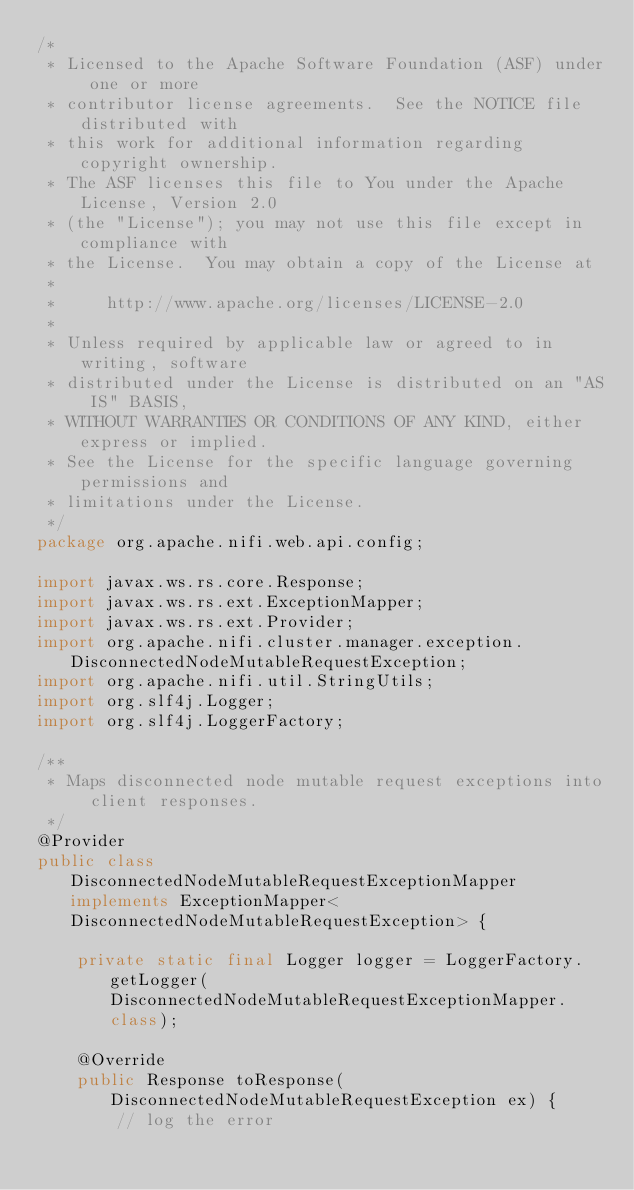<code> <loc_0><loc_0><loc_500><loc_500><_Java_>/*
 * Licensed to the Apache Software Foundation (ASF) under one or more
 * contributor license agreements.  See the NOTICE file distributed with
 * this work for additional information regarding copyright ownership.
 * The ASF licenses this file to You under the Apache License, Version 2.0
 * (the "License"); you may not use this file except in compliance with
 * the License.  You may obtain a copy of the License at
 *
 *     http://www.apache.org/licenses/LICENSE-2.0
 *
 * Unless required by applicable law or agreed to in writing, software
 * distributed under the License is distributed on an "AS IS" BASIS,
 * WITHOUT WARRANTIES OR CONDITIONS OF ANY KIND, either express or implied.
 * See the License for the specific language governing permissions and
 * limitations under the License.
 */
package org.apache.nifi.web.api.config;

import javax.ws.rs.core.Response;
import javax.ws.rs.ext.ExceptionMapper;
import javax.ws.rs.ext.Provider;
import org.apache.nifi.cluster.manager.exception.DisconnectedNodeMutableRequestException;
import org.apache.nifi.util.StringUtils;
import org.slf4j.Logger;
import org.slf4j.LoggerFactory;

/**
 * Maps disconnected node mutable request exceptions into client responses.
 */
@Provider
public class DisconnectedNodeMutableRequestExceptionMapper implements ExceptionMapper<DisconnectedNodeMutableRequestException> {

    private static final Logger logger = LoggerFactory.getLogger(DisconnectedNodeMutableRequestExceptionMapper.class);

    @Override
    public Response toResponse(DisconnectedNodeMutableRequestException ex) {
        // log the error</code> 